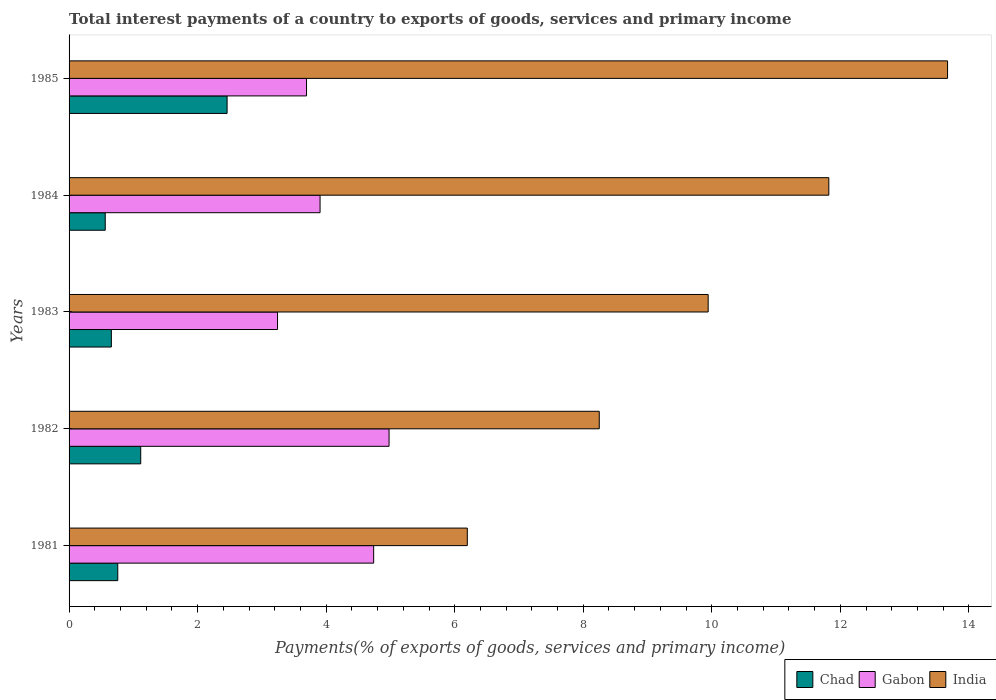Are the number of bars on each tick of the Y-axis equal?
Give a very brief answer. Yes. What is the label of the 4th group of bars from the top?
Keep it short and to the point. 1982. In how many cases, is the number of bars for a given year not equal to the number of legend labels?
Offer a terse response. 0. What is the total interest payments in Gabon in 1981?
Provide a short and direct response. 4.74. Across all years, what is the maximum total interest payments in India?
Keep it short and to the point. 13.67. Across all years, what is the minimum total interest payments in India?
Offer a terse response. 6.2. In which year was the total interest payments in Chad maximum?
Provide a short and direct response. 1985. What is the total total interest payments in Gabon in the graph?
Your answer should be compact. 20.56. What is the difference between the total interest payments in India in 1981 and that in 1985?
Make the answer very short. -7.47. What is the difference between the total interest payments in Gabon in 1984 and the total interest payments in Chad in 1982?
Your answer should be very brief. 2.79. What is the average total interest payments in Chad per year?
Your response must be concise. 1.11. In the year 1984, what is the difference between the total interest payments in Gabon and total interest payments in India?
Make the answer very short. -7.92. What is the ratio of the total interest payments in Gabon in 1982 to that in 1983?
Provide a short and direct response. 1.54. Is the total interest payments in India in 1983 less than that in 1984?
Your answer should be very brief. Yes. What is the difference between the highest and the second highest total interest payments in Gabon?
Offer a terse response. 0.24. What is the difference between the highest and the lowest total interest payments in India?
Give a very brief answer. 7.47. In how many years, is the total interest payments in Gabon greater than the average total interest payments in Gabon taken over all years?
Ensure brevity in your answer.  2. What does the 3rd bar from the bottom in 1982 represents?
Your response must be concise. India. How many years are there in the graph?
Offer a terse response. 5. Are the values on the major ticks of X-axis written in scientific E-notation?
Your answer should be very brief. No. Does the graph contain any zero values?
Give a very brief answer. No. What is the title of the graph?
Provide a short and direct response. Total interest payments of a country to exports of goods, services and primary income. Does "Uruguay" appear as one of the legend labels in the graph?
Provide a short and direct response. No. What is the label or title of the X-axis?
Offer a terse response. Payments(% of exports of goods, services and primary income). What is the Payments(% of exports of goods, services and primary income) of Chad in 1981?
Provide a short and direct response. 0.76. What is the Payments(% of exports of goods, services and primary income) in Gabon in 1981?
Provide a succinct answer. 4.74. What is the Payments(% of exports of goods, services and primary income) in India in 1981?
Your answer should be compact. 6.2. What is the Payments(% of exports of goods, services and primary income) of Chad in 1982?
Give a very brief answer. 1.11. What is the Payments(% of exports of goods, services and primary income) in Gabon in 1982?
Keep it short and to the point. 4.98. What is the Payments(% of exports of goods, services and primary income) of India in 1982?
Provide a succinct answer. 8.25. What is the Payments(% of exports of goods, services and primary income) of Chad in 1983?
Offer a terse response. 0.66. What is the Payments(% of exports of goods, services and primary income) of Gabon in 1983?
Ensure brevity in your answer.  3.24. What is the Payments(% of exports of goods, services and primary income) in India in 1983?
Your response must be concise. 9.94. What is the Payments(% of exports of goods, services and primary income) of Chad in 1984?
Provide a short and direct response. 0.56. What is the Payments(% of exports of goods, services and primary income) in Gabon in 1984?
Offer a very short reply. 3.91. What is the Payments(% of exports of goods, services and primary income) in India in 1984?
Provide a succinct answer. 11.82. What is the Payments(% of exports of goods, services and primary income) of Chad in 1985?
Give a very brief answer. 2.46. What is the Payments(% of exports of goods, services and primary income) of Gabon in 1985?
Your answer should be very brief. 3.69. What is the Payments(% of exports of goods, services and primary income) in India in 1985?
Offer a terse response. 13.67. Across all years, what is the maximum Payments(% of exports of goods, services and primary income) of Chad?
Your response must be concise. 2.46. Across all years, what is the maximum Payments(% of exports of goods, services and primary income) of Gabon?
Provide a succinct answer. 4.98. Across all years, what is the maximum Payments(% of exports of goods, services and primary income) in India?
Offer a very short reply. 13.67. Across all years, what is the minimum Payments(% of exports of goods, services and primary income) in Chad?
Your answer should be compact. 0.56. Across all years, what is the minimum Payments(% of exports of goods, services and primary income) in Gabon?
Give a very brief answer. 3.24. Across all years, what is the minimum Payments(% of exports of goods, services and primary income) of India?
Offer a very short reply. 6.2. What is the total Payments(% of exports of goods, services and primary income) in Chad in the graph?
Ensure brevity in your answer.  5.55. What is the total Payments(% of exports of goods, services and primary income) in Gabon in the graph?
Give a very brief answer. 20.56. What is the total Payments(% of exports of goods, services and primary income) in India in the graph?
Provide a succinct answer. 49.88. What is the difference between the Payments(% of exports of goods, services and primary income) in Chad in 1981 and that in 1982?
Give a very brief answer. -0.36. What is the difference between the Payments(% of exports of goods, services and primary income) in Gabon in 1981 and that in 1982?
Keep it short and to the point. -0.24. What is the difference between the Payments(% of exports of goods, services and primary income) in India in 1981 and that in 1982?
Offer a very short reply. -2.05. What is the difference between the Payments(% of exports of goods, services and primary income) of Chad in 1981 and that in 1983?
Ensure brevity in your answer.  0.1. What is the difference between the Payments(% of exports of goods, services and primary income) of Gabon in 1981 and that in 1983?
Offer a very short reply. 1.5. What is the difference between the Payments(% of exports of goods, services and primary income) of India in 1981 and that in 1983?
Give a very brief answer. -3.75. What is the difference between the Payments(% of exports of goods, services and primary income) in Chad in 1981 and that in 1984?
Ensure brevity in your answer.  0.19. What is the difference between the Payments(% of exports of goods, services and primary income) of Gabon in 1981 and that in 1984?
Provide a short and direct response. 0.83. What is the difference between the Payments(% of exports of goods, services and primary income) in India in 1981 and that in 1984?
Offer a terse response. -5.62. What is the difference between the Payments(% of exports of goods, services and primary income) of Chad in 1981 and that in 1985?
Keep it short and to the point. -1.7. What is the difference between the Payments(% of exports of goods, services and primary income) of Gabon in 1981 and that in 1985?
Provide a succinct answer. 1.04. What is the difference between the Payments(% of exports of goods, services and primary income) in India in 1981 and that in 1985?
Give a very brief answer. -7.47. What is the difference between the Payments(% of exports of goods, services and primary income) of Chad in 1982 and that in 1983?
Make the answer very short. 0.46. What is the difference between the Payments(% of exports of goods, services and primary income) of Gabon in 1982 and that in 1983?
Keep it short and to the point. 1.74. What is the difference between the Payments(% of exports of goods, services and primary income) in India in 1982 and that in 1983?
Provide a succinct answer. -1.69. What is the difference between the Payments(% of exports of goods, services and primary income) in Chad in 1982 and that in 1984?
Provide a short and direct response. 0.55. What is the difference between the Payments(% of exports of goods, services and primary income) in Gabon in 1982 and that in 1984?
Give a very brief answer. 1.07. What is the difference between the Payments(% of exports of goods, services and primary income) of India in 1982 and that in 1984?
Offer a very short reply. -3.57. What is the difference between the Payments(% of exports of goods, services and primary income) of Chad in 1982 and that in 1985?
Make the answer very short. -1.34. What is the difference between the Payments(% of exports of goods, services and primary income) in Gabon in 1982 and that in 1985?
Offer a very short reply. 1.28. What is the difference between the Payments(% of exports of goods, services and primary income) of India in 1982 and that in 1985?
Keep it short and to the point. -5.42. What is the difference between the Payments(% of exports of goods, services and primary income) in Chad in 1983 and that in 1984?
Give a very brief answer. 0.1. What is the difference between the Payments(% of exports of goods, services and primary income) of Gabon in 1983 and that in 1984?
Ensure brevity in your answer.  -0.66. What is the difference between the Payments(% of exports of goods, services and primary income) of India in 1983 and that in 1984?
Provide a short and direct response. -1.88. What is the difference between the Payments(% of exports of goods, services and primary income) in Chad in 1983 and that in 1985?
Provide a succinct answer. -1.8. What is the difference between the Payments(% of exports of goods, services and primary income) of Gabon in 1983 and that in 1985?
Make the answer very short. -0.45. What is the difference between the Payments(% of exports of goods, services and primary income) of India in 1983 and that in 1985?
Ensure brevity in your answer.  -3.72. What is the difference between the Payments(% of exports of goods, services and primary income) of Chad in 1984 and that in 1985?
Make the answer very short. -1.9. What is the difference between the Payments(% of exports of goods, services and primary income) of Gabon in 1984 and that in 1985?
Offer a very short reply. 0.21. What is the difference between the Payments(% of exports of goods, services and primary income) in India in 1984 and that in 1985?
Make the answer very short. -1.85. What is the difference between the Payments(% of exports of goods, services and primary income) of Chad in 1981 and the Payments(% of exports of goods, services and primary income) of Gabon in 1982?
Ensure brevity in your answer.  -4.22. What is the difference between the Payments(% of exports of goods, services and primary income) of Chad in 1981 and the Payments(% of exports of goods, services and primary income) of India in 1982?
Give a very brief answer. -7.49. What is the difference between the Payments(% of exports of goods, services and primary income) of Gabon in 1981 and the Payments(% of exports of goods, services and primary income) of India in 1982?
Your answer should be very brief. -3.51. What is the difference between the Payments(% of exports of goods, services and primary income) of Chad in 1981 and the Payments(% of exports of goods, services and primary income) of Gabon in 1983?
Provide a succinct answer. -2.49. What is the difference between the Payments(% of exports of goods, services and primary income) in Chad in 1981 and the Payments(% of exports of goods, services and primary income) in India in 1983?
Give a very brief answer. -9.19. What is the difference between the Payments(% of exports of goods, services and primary income) of Gabon in 1981 and the Payments(% of exports of goods, services and primary income) of India in 1983?
Your response must be concise. -5.2. What is the difference between the Payments(% of exports of goods, services and primary income) in Chad in 1981 and the Payments(% of exports of goods, services and primary income) in Gabon in 1984?
Provide a succinct answer. -3.15. What is the difference between the Payments(% of exports of goods, services and primary income) of Chad in 1981 and the Payments(% of exports of goods, services and primary income) of India in 1984?
Your response must be concise. -11.06. What is the difference between the Payments(% of exports of goods, services and primary income) of Gabon in 1981 and the Payments(% of exports of goods, services and primary income) of India in 1984?
Provide a succinct answer. -7.08. What is the difference between the Payments(% of exports of goods, services and primary income) in Chad in 1981 and the Payments(% of exports of goods, services and primary income) in Gabon in 1985?
Provide a succinct answer. -2.94. What is the difference between the Payments(% of exports of goods, services and primary income) in Chad in 1981 and the Payments(% of exports of goods, services and primary income) in India in 1985?
Keep it short and to the point. -12.91. What is the difference between the Payments(% of exports of goods, services and primary income) in Gabon in 1981 and the Payments(% of exports of goods, services and primary income) in India in 1985?
Your answer should be very brief. -8.93. What is the difference between the Payments(% of exports of goods, services and primary income) of Chad in 1982 and the Payments(% of exports of goods, services and primary income) of Gabon in 1983?
Give a very brief answer. -2.13. What is the difference between the Payments(% of exports of goods, services and primary income) in Chad in 1982 and the Payments(% of exports of goods, services and primary income) in India in 1983?
Offer a very short reply. -8.83. What is the difference between the Payments(% of exports of goods, services and primary income) in Gabon in 1982 and the Payments(% of exports of goods, services and primary income) in India in 1983?
Make the answer very short. -4.96. What is the difference between the Payments(% of exports of goods, services and primary income) in Chad in 1982 and the Payments(% of exports of goods, services and primary income) in Gabon in 1984?
Ensure brevity in your answer.  -2.79. What is the difference between the Payments(% of exports of goods, services and primary income) of Chad in 1982 and the Payments(% of exports of goods, services and primary income) of India in 1984?
Keep it short and to the point. -10.71. What is the difference between the Payments(% of exports of goods, services and primary income) in Gabon in 1982 and the Payments(% of exports of goods, services and primary income) in India in 1984?
Offer a very short reply. -6.84. What is the difference between the Payments(% of exports of goods, services and primary income) in Chad in 1982 and the Payments(% of exports of goods, services and primary income) in Gabon in 1985?
Give a very brief answer. -2.58. What is the difference between the Payments(% of exports of goods, services and primary income) in Chad in 1982 and the Payments(% of exports of goods, services and primary income) in India in 1985?
Ensure brevity in your answer.  -12.55. What is the difference between the Payments(% of exports of goods, services and primary income) of Gabon in 1982 and the Payments(% of exports of goods, services and primary income) of India in 1985?
Keep it short and to the point. -8.69. What is the difference between the Payments(% of exports of goods, services and primary income) of Chad in 1983 and the Payments(% of exports of goods, services and primary income) of Gabon in 1984?
Make the answer very short. -3.25. What is the difference between the Payments(% of exports of goods, services and primary income) in Chad in 1983 and the Payments(% of exports of goods, services and primary income) in India in 1984?
Your answer should be compact. -11.16. What is the difference between the Payments(% of exports of goods, services and primary income) in Gabon in 1983 and the Payments(% of exports of goods, services and primary income) in India in 1984?
Your response must be concise. -8.58. What is the difference between the Payments(% of exports of goods, services and primary income) in Chad in 1983 and the Payments(% of exports of goods, services and primary income) in Gabon in 1985?
Give a very brief answer. -3.04. What is the difference between the Payments(% of exports of goods, services and primary income) in Chad in 1983 and the Payments(% of exports of goods, services and primary income) in India in 1985?
Provide a succinct answer. -13.01. What is the difference between the Payments(% of exports of goods, services and primary income) in Gabon in 1983 and the Payments(% of exports of goods, services and primary income) in India in 1985?
Provide a short and direct response. -10.42. What is the difference between the Payments(% of exports of goods, services and primary income) of Chad in 1984 and the Payments(% of exports of goods, services and primary income) of Gabon in 1985?
Keep it short and to the point. -3.13. What is the difference between the Payments(% of exports of goods, services and primary income) in Chad in 1984 and the Payments(% of exports of goods, services and primary income) in India in 1985?
Your response must be concise. -13.11. What is the difference between the Payments(% of exports of goods, services and primary income) of Gabon in 1984 and the Payments(% of exports of goods, services and primary income) of India in 1985?
Keep it short and to the point. -9.76. What is the average Payments(% of exports of goods, services and primary income) of Chad per year?
Keep it short and to the point. 1.11. What is the average Payments(% of exports of goods, services and primary income) of Gabon per year?
Provide a succinct answer. 4.11. What is the average Payments(% of exports of goods, services and primary income) of India per year?
Give a very brief answer. 9.98. In the year 1981, what is the difference between the Payments(% of exports of goods, services and primary income) of Chad and Payments(% of exports of goods, services and primary income) of Gabon?
Your response must be concise. -3.98. In the year 1981, what is the difference between the Payments(% of exports of goods, services and primary income) in Chad and Payments(% of exports of goods, services and primary income) in India?
Keep it short and to the point. -5.44. In the year 1981, what is the difference between the Payments(% of exports of goods, services and primary income) in Gabon and Payments(% of exports of goods, services and primary income) in India?
Offer a terse response. -1.46. In the year 1982, what is the difference between the Payments(% of exports of goods, services and primary income) of Chad and Payments(% of exports of goods, services and primary income) of Gabon?
Give a very brief answer. -3.86. In the year 1982, what is the difference between the Payments(% of exports of goods, services and primary income) in Chad and Payments(% of exports of goods, services and primary income) in India?
Provide a short and direct response. -7.13. In the year 1982, what is the difference between the Payments(% of exports of goods, services and primary income) in Gabon and Payments(% of exports of goods, services and primary income) in India?
Make the answer very short. -3.27. In the year 1983, what is the difference between the Payments(% of exports of goods, services and primary income) in Chad and Payments(% of exports of goods, services and primary income) in Gabon?
Offer a very short reply. -2.59. In the year 1983, what is the difference between the Payments(% of exports of goods, services and primary income) in Chad and Payments(% of exports of goods, services and primary income) in India?
Make the answer very short. -9.29. In the year 1983, what is the difference between the Payments(% of exports of goods, services and primary income) in Gabon and Payments(% of exports of goods, services and primary income) in India?
Offer a terse response. -6.7. In the year 1984, what is the difference between the Payments(% of exports of goods, services and primary income) of Chad and Payments(% of exports of goods, services and primary income) of Gabon?
Make the answer very short. -3.34. In the year 1984, what is the difference between the Payments(% of exports of goods, services and primary income) in Chad and Payments(% of exports of goods, services and primary income) in India?
Your answer should be very brief. -11.26. In the year 1984, what is the difference between the Payments(% of exports of goods, services and primary income) in Gabon and Payments(% of exports of goods, services and primary income) in India?
Provide a short and direct response. -7.92. In the year 1985, what is the difference between the Payments(% of exports of goods, services and primary income) of Chad and Payments(% of exports of goods, services and primary income) of Gabon?
Ensure brevity in your answer.  -1.24. In the year 1985, what is the difference between the Payments(% of exports of goods, services and primary income) in Chad and Payments(% of exports of goods, services and primary income) in India?
Your answer should be very brief. -11.21. In the year 1985, what is the difference between the Payments(% of exports of goods, services and primary income) in Gabon and Payments(% of exports of goods, services and primary income) in India?
Your response must be concise. -9.97. What is the ratio of the Payments(% of exports of goods, services and primary income) in Chad in 1981 to that in 1982?
Offer a terse response. 0.68. What is the ratio of the Payments(% of exports of goods, services and primary income) in Gabon in 1981 to that in 1982?
Provide a short and direct response. 0.95. What is the ratio of the Payments(% of exports of goods, services and primary income) in India in 1981 to that in 1982?
Provide a short and direct response. 0.75. What is the ratio of the Payments(% of exports of goods, services and primary income) in Chad in 1981 to that in 1983?
Your response must be concise. 1.15. What is the ratio of the Payments(% of exports of goods, services and primary income) in Gabon in 1981 to that in 1983?
Your response must be concise. 1.46. What is the ratio of the Payments(% of exports of goods, services and primary income) of India in 1981 to that in 1983?
Keep it short and to the point. 0.62. What is the ratio of the Payments(% of exports of goods, services and primary income) of Chad in 1981 to that in 1984?
Your response must be concise. 1.35. What is the ratio of the Payments(% of exports of goods, services and primary income) of Gabon in 1981 to that in 1984?
Keep it short and to the point. 1.21. What is the ratio of the Payments(% of exports of goods, services and primary income) in India in 1981 to that in 1984?
Offer a very short reply. 0.52. What is the ratio of the Payments(% of exports of goods, services and primary income) in Chad in 1981 to that in 1985?
Make the answer very short. 0.31. What is the ratio of the Payments(% of exports of goods, services and primary income) in Gabon in 1981 to that in 1985?
Make the answer very short. 1.28. What is the ratio of the Payments(% of exports of goods, services and primary income) of India in 1981 to that in 1985?
Provide a short and direct response. 0.45. What is the ratio of the Payments(% of exports of goods, services and primary income) in Chad in 1982 to that in 1983?
Offer a very short reply. 1.69. What is the ratio of the Payments(% of exports of goods, services and primary income) of Gabon in 1982 to that in 1983?
Keep it short and to the point. 1.53. What is the ratio of the Payments(% of exports of goods, services and primary income) in India in 1982 to that in 1983?
Offer a terse response. 0.83. What is the ratio of the Payments(% of exports of goods, services and primary income) of Chad in 1982 to that in 1984?
Your response must be concise. 1.98. What is the ratio of the Payments(% of exports of goods, services and primary income) of Gabon in 1982 to that in 1984?
Make the answer very short. 1.27. What is the ratio of the Payments(% of exports of goods, services and primary income) of India in 1982 to that in 1984?
Offer a terse response. 0.7. What is the ratio of the Payments(% of exports of goods, services and primary income) of Chad in 1982 to that in 1985?
Offer a terse response. 0.45. What is the ratio of the Payments(% of exports of goods, services and primary income) of Gabon in 1982 to that in 1985?
Make the answer very short. 1.35. What is the ratio of the Payments(% of exports of goods, services and primary income) in India in 1982 to that in 1985?
Offer a very short reply. 0.6. What is the ratio of the Payments(% of exports of goods, services and primary income) in Chad in 1983 to that in 1984?
Keep it short and to the point. 1.17. What is the ratio of the Payments(% of exports of goods, services and primary income) in Gabon in 1983 to that in 1984?
Your response must be concise. 0.83. What is the ratio of the Payments(% of exports of goods, services and primary income) in India in 1983 to that in 1984?
Your response must be concise. 0.84. What is the ratio of the Payments(% of exports of goods, services and primary income) in Chad in 1983 to that in 1985?
Your answer should be very brief. 0.27. What is the ratio of the Payments(% of exports of goods, services and primary income) of Gabon in 1983 to that in 1985?
Your answer should be very brief. 0.88. What is the ratio of the Payments(% of exports of goods, services and primary income) in India in 1983 to that in 1985?
Provide a succinct answer. 0.73. What is the ratio of the Payments(% of exports of goods, services and primary income) of Chad in 1984 to that in 1985?
Keep it short and to the point. 0.23. What is the ratio of the Payments(% of exports of goods, services and primary income) in Gabon in 1984 to that in 1985?
Keep it short and to the point. 1.06. What is the ratio of the Payments(% of exports of goods, services and primary income) in India in 1984 to that in 1985?
Keep it short and to the point. 0.86. What is the difference between the highest and the second highest Payments(% of exports of goods, services and primary income) of Chad?
Your answer should be very brief. 1.34. What is the difference between the highest and the second highest Payments(% of exports of goods, services and primary income) in Gabon?
Provide a short and direct response. 0.24. What is the difference between the highest and the second highest Payments(% of exports of goods, services and primary income) in India?
Provide a succinct answer. 1.85. What is the difference between the highest and the lowest Payments(% of exports of goods, services and primary income) in Chad?
Make the answer very short. 1.9. What is the difference between the highest and the lowest Payments(% of exports of goods, services and primary income) in Gabon?
Your answer should be compact. 1.74. What is the difference between the highest and the lowest Payments(% of exports of goods, services and primary income) in India?
Your response must be concise. 7.47. 